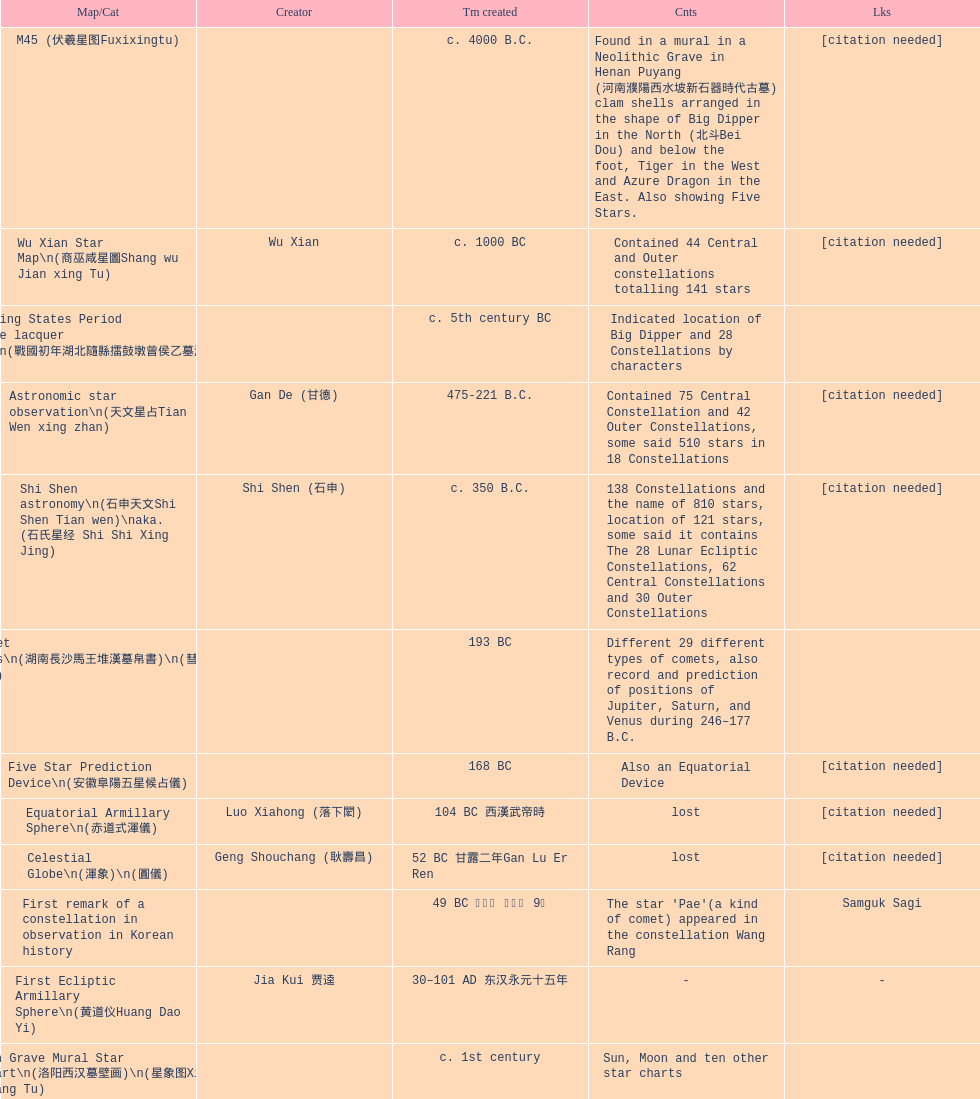What is the difference between the five star prediction device's date of creation and the han comet diagrams' date of creation? 25 years. 